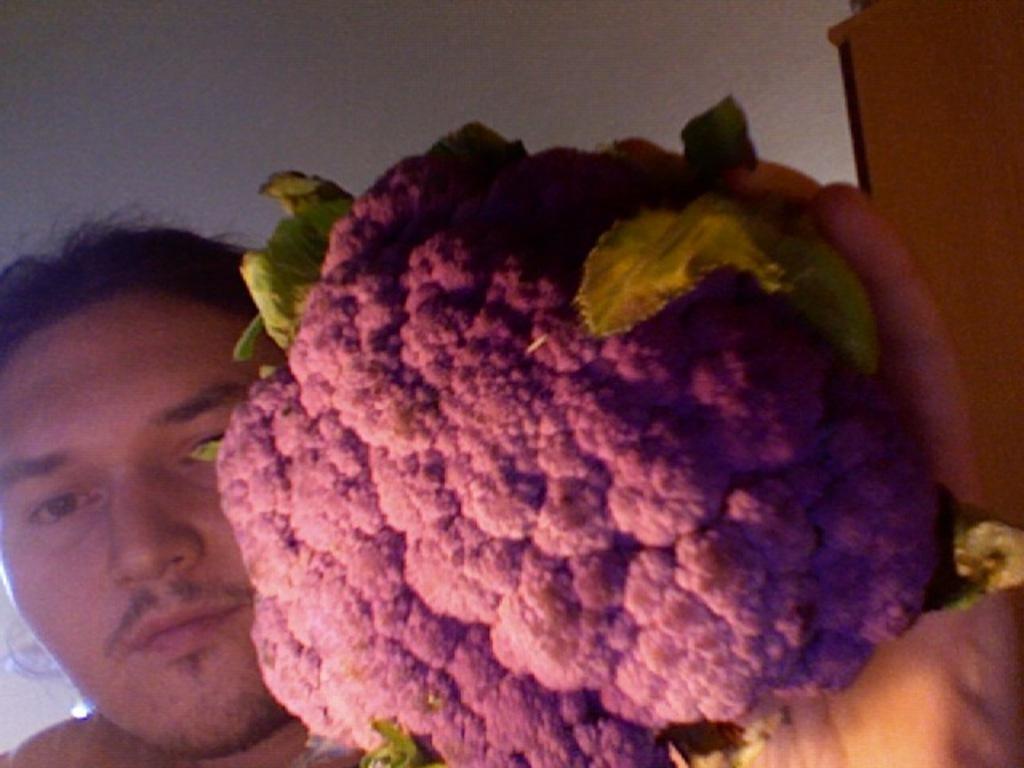Can you describe this image briefly? In this image I can see a person holding a cauliflower in the hand and looking at the picture. On the right side there is a cupboard. In the background there is a wall. 